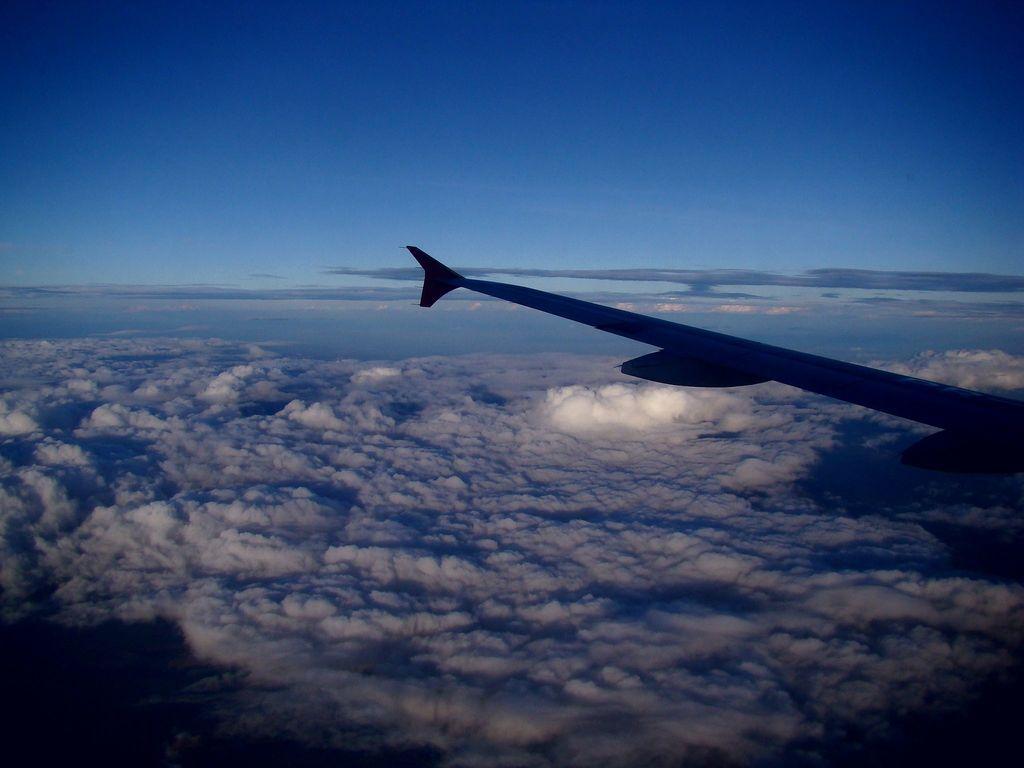Please provide a concise description of this image. In this image we can see wing of a plane on the right side. In the background we can see sky and clouds. 